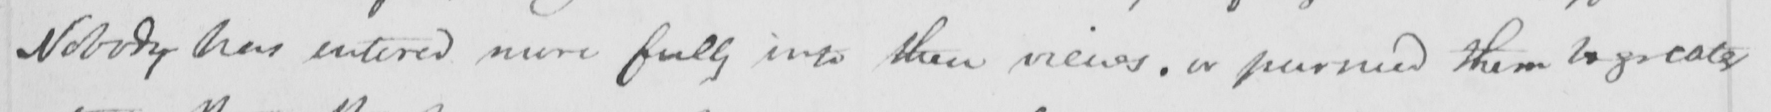Please provide the text content of this handwritten line. Nobody has entered more fully into their views , or pursued them logically 